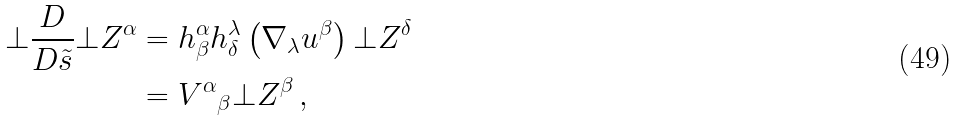Convert formula to latex. <formula><loc_0><loc_0><loc_500><loc_500>\bot \frac { D } { D \tilde { s } } \bot Z ^ { \alpha } & = h ^ { \alpha } _ { \beta } h ^ { \lambda } _ { \delta } \left ( \nabla _ { \lambda } u ^ { \beta } \right ) \bot Z ^ { \delta } \\ & = { V ^ { \alpha } } _ { \beta } \bot Z ^ { \beta } \, ,</formula> 